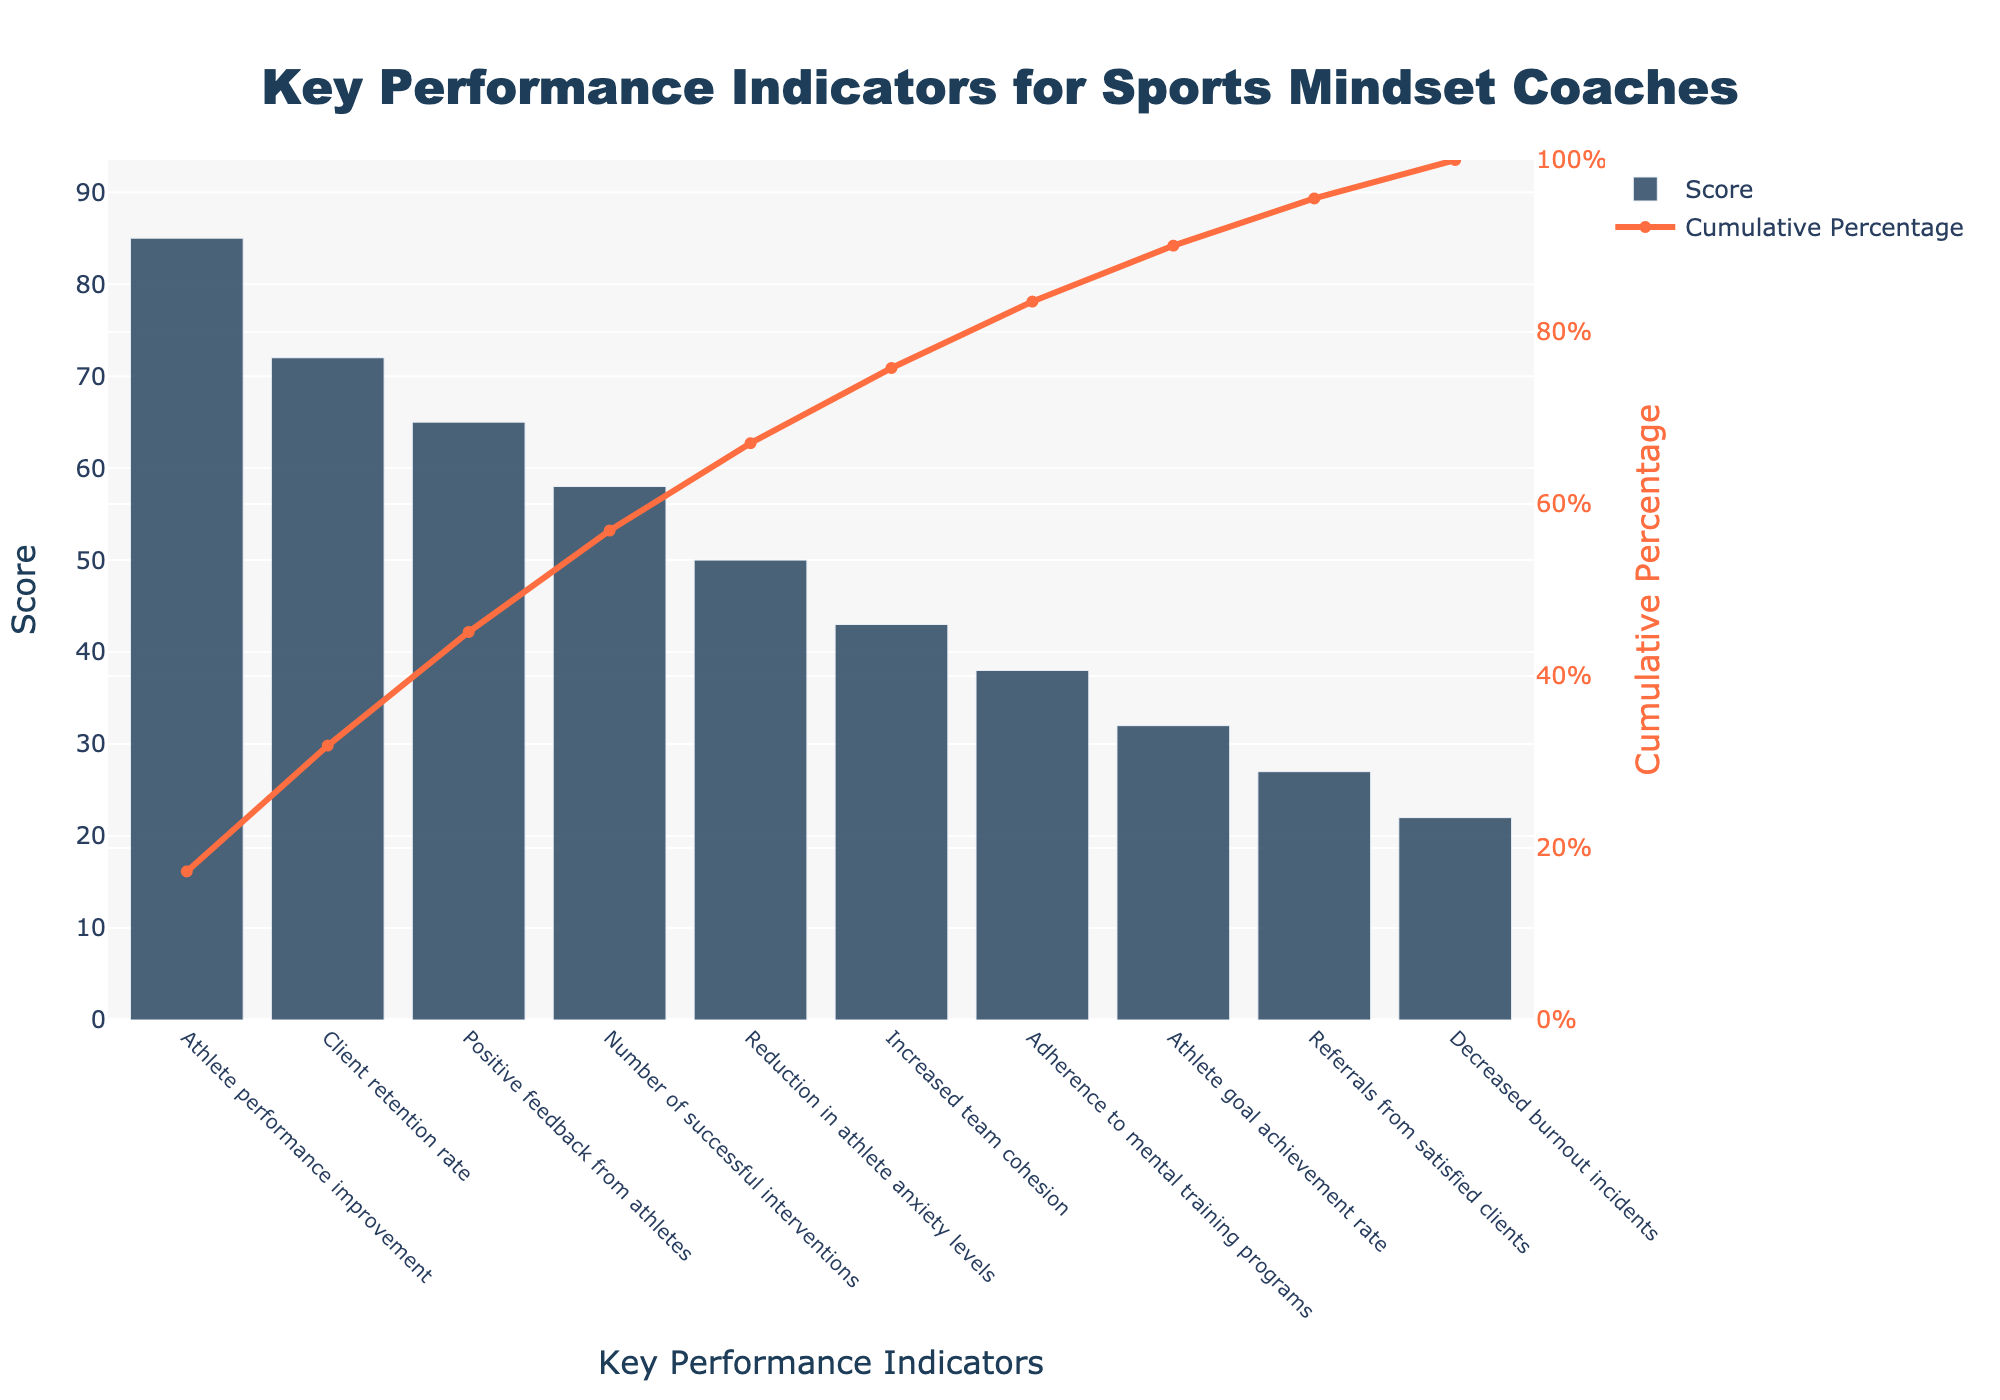What is the title of the Pareto chart? The title of the chart is displayed prominently at the top of the figure. It reads "Key Performance Indicators for Sports Mindset Coaches."
Answer: Key Performance Indicators for Sports Mindset Coaches Which KPI has the highest score? The KPI with the highest score can be identified by looking at the bar with the greatest height. This bar represents "Athlete performance improvement" with a score of 85.
Answer: Athlete performance improvement What is the cumulative percentage at the "Positive feedback from athletes" KPI? The cumulative percentage line intersects the "Positive feedback from athletes" KPI, which is marked at 65. To find the cumulative percentage, look at the y-axis on the right side.
Answer: 71% What is the cumulative percentage after the first three KPIs? The first three KPIs are "Athlete performance improvement", "Client retention rate", and "Positive feedback from athletes". Add their scores (85 + 72 + 65) to get 222. Divide by the total sum of scores (492) and multiply by 100.
Answer: 45.12% Which KPI has the smallest score? The KPI with the smallest score can be identified by looking at the shortest bar in the chart, which represents "Decreased burnout incidents" with a score of 22.
Answer: Decreased burnout incidents How many Key Performance Indicators are displayed in the chart? Count the number of bars representing different KPIs. There are 10 bars, one for each KPI.
Answer: 10 How does the "Reduction in athlete anxiety levels" score compare to "Number of successful interventions"? The score for "Reduction in athlete anxiety levels" is 50, while "Number of successful interventions" is 58. Comparing the two, 50 is less than 58.
Answer: Less What is the cumulative percentage just after the "Number of successful interventions" KPI? Add the scores up to and including "Number of successful interventions": (85 + 72 + 65 + 58). The sum is 280. Divide this by the total sum of scores (492) and multiply by 100.
Answer: 56.91% Which KPI contributes to crossing the 50% cumulative percentage mark? By looking at the cumulative percentage line, the KPI where it surpasses 50% is "Number of successful interventions."
Answer: Number of successful interventions Calculate the average score of the bottom five KPIs. The bottom five KPIs are "Adherence to mental training programs", "Athlete goal achievement rate", "Referrals from satisfied clients", "Decreased burnout incidents", and "Increased team cohesion" with scores 38, 32, 27, 22, and 43. Sum these values (38 + 32 + 27 + 22 + 43) and divide by 5.
Answer: 32.4 